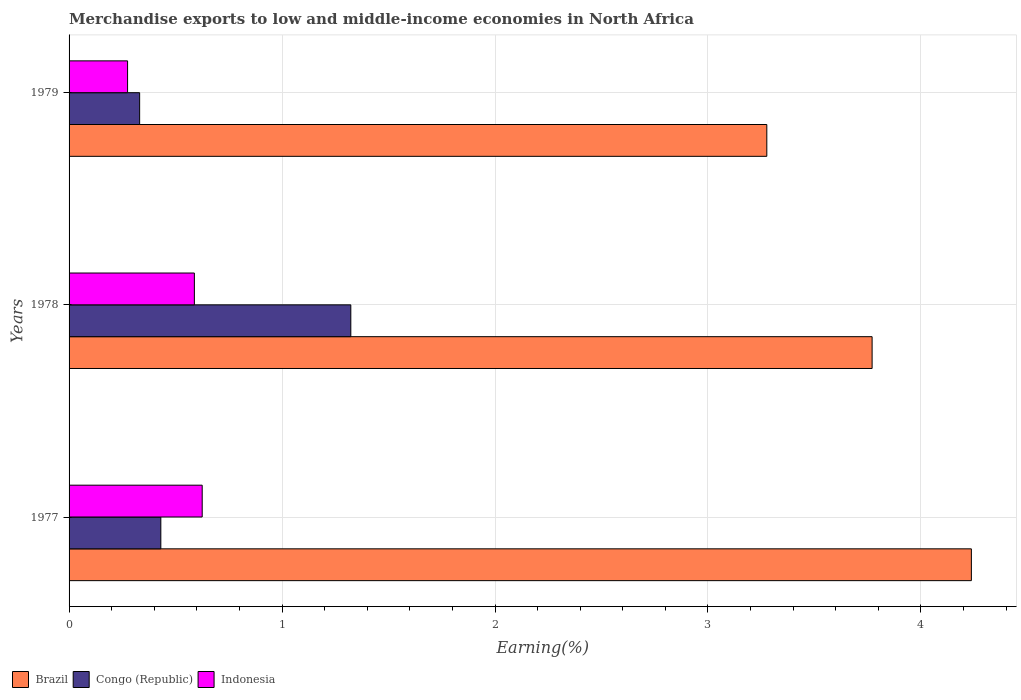How many groups of bars are there?
Your response must be concise. 3. How many bars are there on the 2nd tick from the top?
Offer a terse response. 3. What is the label of the 2nd group of bars from the top?
Ensure brevity in your answer.  1978. What is the percentage of amount earned from merchandise exports in Brazil in 1979?
Your response must be concise. 3.28. Across all years, what is the maximum percentage of amount earned from merchandise exports in Brazil?
Provide a short and direct response. 4.24. Across all years, what is the minimum percentage of amount earned from merchandise exports in Congo (Republic)?
Give a very brief answer. 0.33. In which year was the percentage of amount earned from merchandise exports in Congo (Republic) maximum?
Keep it short and to the point. 1978. In which year was the percentage of amount earned from merchandise exports in Indonesia minimum?
Your response must be concise. 1979. What is the total percentage of amount earned from merchandise exports in Congo (Republic) in the graph?
Give a very brief answer. 2.09. What is the difference between the percentage of amount earned from merchandise exports in Brazil in 1977 and that in 1979?
Provide a succinct answer. 0.96. What is the difference between the percentage of amount earned from merchandise exports in Congo (Republic) in 1979 and the percentage of amount earned from merchandise exports in Brazil in 1977?
Offer a terse response. -3.91. What is the average percentage of amount earned from merchandise exports in Congo (Republic) per year?
Provide a succinct answer. 0.7. In the year 1979, what is the difference between the percentage of amount earned from merchandise exports in Indonesia and percentage of amount earned from merchandise exports in Brazil?
Offer a very short reply. -3. What is the ratio of the percentage of amount earned from merchandise exports in Indonesia in 1977 to that in 1979?
Your answer should be compact. 2.28. Is the difference between the percentage of amount earned from merchandise exports in Indonesia in 1977 and 1979 greater than the difference between the percentage of amount earned from merchandise exports in Brazil in 1977 and 1979?
Make the answer very short. No. What is the difference between the highest and the second highest percentage of amount earned from merchandise exports in Indonesia?
Make the answer very short. 0.04. What is the difference between the highest and the lowest percentage of amount earned from merchandise exports in Indonesia?
Offer a very short reply. 0.35. In how many years, is the percentage of amount earned from merchandise exports in Congo (Republic) greater than the average percentage of amount earned from merchandise exports in Congo (Republic) taken over all years?
Provide a short and direct response. 1. Is the sum of the percentage of amount earned from merchandise exports in Brazil in 1977 and 1979 greater than the maximum percentage of amount earned from merchandise exports in Indonesia across all years?
Your answer should be very brief. Yes. What does the 1st bar from the top in 1978 represents?
Your answer should be very brief. Indonesia. Are all the bars in the graph horizontal?
Make the answer very short. Yes. How many years are there in the graph?
Make the answer very short. 3. How many legend labels are there?
Provide a succinct answer. 3. How are the legend labels stacked?
Provide a short and direct response. Horizontal. What is the title of the graph?
Ensure brevity in your answer.  Merchandise exports to low and middle-income economies in North Africa. Does "Belarus" appear as one of the legend labels in the graph?
Provide a short and direct response. No. What is the label or title of the X-axis?
Your answer should be very brief. Earning(%). What is the label or title of the Y-axis?
Your answer should be very brief. Years. What is the Earning(%) of Brazil in 1977?
Provide a succinct answer. 4.24. What is the Earning(%) in Congo (Republic) in 1977?
Provide a short and direct response. 0.43. What is the Earning(%) in Indonesia in 1977?
Keep it short and to the point. 0.63. What is the Earning(%) of Brazil in 1978?
Make the answer very short. 3.77. What is the Earning(%) of Congo (Republic) in 1978?
Your answer should be compact. 1.32. What is the Earning(%) in Indonesia in 1978?
Your response must be concise. 0.59. What is the Earning(%) in Brazil in 1979?
Offer a terse response. 3.28. What is the Earning(%) in Congo (Republic) in 1979?
Ensure brevity in your answer.  0.33. What is the Earning(%) in Indonesia in 1979?
Your answer should be compact. 0.27. Across all years, what is the maximum Earning(%) of Brazil?
Provide a succinct answer. 4.24. Across all years, what is the maximum Earning(%) of Congo (Republic)?
Make the answer very short. 1.32. Across all years, what is the maximum Earning(%) in Indonesia?
Your answer should be very brief. 0.63. Across all years, what is the minimum Earning(%) of Brazil?
Offer a terse response. 3.28. Across all years, what is the minimum Earning(%) in Congo (Republic)?
Offer a very short reply. 0.33. Across all years, what is the minimum Earning(%) of Indonesia?
Your answer should be compact. 0.27. What is the total Earning(%) in Brazil in the graph?
Provide a short and direct response. 11.28. What is the total Earning(%) of Congo (Republic) in the graph?
Offer a very short reply. 2.09. What is the total Earning(%) in Indonesia in the graph?
Provide a short and direct response. 1.49. What is the difference between the Earning(%) of Brazil in 1977 and that in 1978?
Your answer should be compact. 0.47. What is the difference between the Earning(%) of Congo (Republic) in 1977 and that in 1978?
Offer a terse response. -0.89. What is the difference between the Earning(%) in Indonesia in 1977 and that in 1978?
Keep it short and to the point. 0.04. What is the difference between the Earning(%) in Brazil in 1977 and that in 1979?
Provide a succinct answer. 0.96. What is the difference between the Earning(%) in Congo (Republic) in 1977 and that in 1979?
Give a very brief answer. 0.1. What is the difference between the Earning(%) in Indonesia in 1977 and that in 1979?
Ensure brevity in your answer.  0.35. What is the difference between the Earning(%) in Brazil in 1978 and that in 1979?
Your response must be concise. 0.49. What is the difference between the Earning(%) in Indonesia in 1978 and that in 1979?
Provide a short and direct response. 0.31. What is the difference between the Earning(%) of Brazil in 1977 and the Earning(%) of Congo (Republic) in 1978?
Your answer should be very brief. 2.91. What is the difference between the Earning(%) of Brazil in 1977 and the Earning(%) of Indonesia in 1978?
Your answer should be compact. 3.65. What is the difference between the Earning(%) of Congo (Republic) in 1977 and the Earning(%) of Indonesia in 1978?
Make the answer very short. -0.16. What is the difference between the Earning(%) of Brazil in 1977 and the Earning(%) of Congo (Republic) in 1979?
Your answer should be very brief. 3.91. What is the difference between the Earning(%) in Brazil in 1977 and the Earning(%) in Indonesia in 1979?
Give a very brief answer. 3.96. What is the difference between the Earning(%) in Congo (Republic) in 1977 and the Earning(%) in Indonesia in 1979?
Offer a very short reply. 0.16. What is the difference between the Earning(%) of Brazil in 1978 and the Earning(%) of Congo (Republic) in 1979?
Keep it short and to the point. 3.44. What is the difference between the Earning(%) in Brazil in 1978 and the Earning(%) in Indonesia in 1979?
Offer a terse response. 3.5. What is the difference between the Earning(%) in Congo (Republic) in 1978 and the Earning(%) in Indonesia in 1979?
Your answer should be compact. 1.05. What is the average Earning(%) of Brazil per year?
Your response must be concise. 3.76. What is the average Earning(%) in Congo (Republic) per year?
Offer a very short reply. 0.7. What is the average Earning(%) in Indonesia per year?
Offer a very short reply. 0.5. In the year 1977, what is the difference between the Earning(%) of Brazil and Earning(%) of Congo (Republic)?
Offer a terse response. 3.81. In the year 1977, what is the difference between the Earning(%) in Brazil and Earning(%) in Indonesia?
Your response must be concise. 3.61. In the year 1977, what is the difference between the Earning(%) of Congo (Republic) and Earning(%) of Indonesia?
Offer a very short reply. -0.19. In the year 1978, what is the difference between the Earning(%) of Brazil and Earning(%) of Congo (Republic)?
Ensure brevity in your answer.  2.45. In the year 1978, what is the difference between the Earning(%) in Brazil and Earning(%) in Indonesia?
Make the answer very short. 3.18. In the year 1978, what is the difference between the Earning(%) in Congo (Republic) and Earning(%) in Indonesia?
Your response must be concise. 0.73. In the year 1979, what is the difference between the Earning(%) of Brazil and Earning(%) of Congo (Republic)?
Ensure brevity in your answer.  2.94. In the year 1979, what is the difference between the Earning(%) in Brazil and Earning(%) in Indonesia?
Keep it short and to the point. 3. In the year 1979, what is the difference between the Earning(%) of Congo (Republic) and Earning(%) of Indonesia?
Make the answer very short. 0.06. What is the ratio of the Earning(%) of Brazil in 1977 to that in 1978?
Keep it short and to the point. 1.12. What is the ratio of the Earning(%) in Congo (Republic) in 1977 to that in 1978?
Ensure brevity in your answer.  0.33. What is the ratio of the Earning(%) of Brazil in 1977 to that in 1979?
Offer a very short reply. 1.29. What is the ratio of the Earning(%) of Congo (Republic) in 1977 to that in 1979?
Your answer should be very brief. 1.3. What is the ratio of the Earning(%) of Indonesia in 1977 to that in 1979?
Keep it short and to the point. 2.28. What is the ratio of the Earning(%) of Brazil in 1978 to that in 1979?
Offer a very short reply. 1.15. What is the ratio of the Earning(%) in Congo (Republic) in 1978 to that in 1979?
Offer a very short reply. 3.99. What is the ratio of the Earning(%) in Indonesia in 1978 to that in 1979?
Keep it short and to the point. 2.14. What is the difference between the highest and the second highest Earning(%) in Brazil?
Keep it short and to the point. 0.47. What is the difference between the highest and the second highest Earning(%) in Congo (Republic)?
Your answer should be very brief. 0.89. What is the difference between the highest and the second highest Earning(%) of Indonesia?
Give a very brief answer. 0.04. What is the difference between the highest and the lowest Earning(%) in Brazil?
Your answer should be very brief. 0.96. What is the difference between the highest and the lowest Earning(%) of Congo (Republic)?
Your answer should be compact. 0.99. What is the difference between the highest and the lowest Earning(%) of Indonesia?
Offer a terse response. 0.35. 